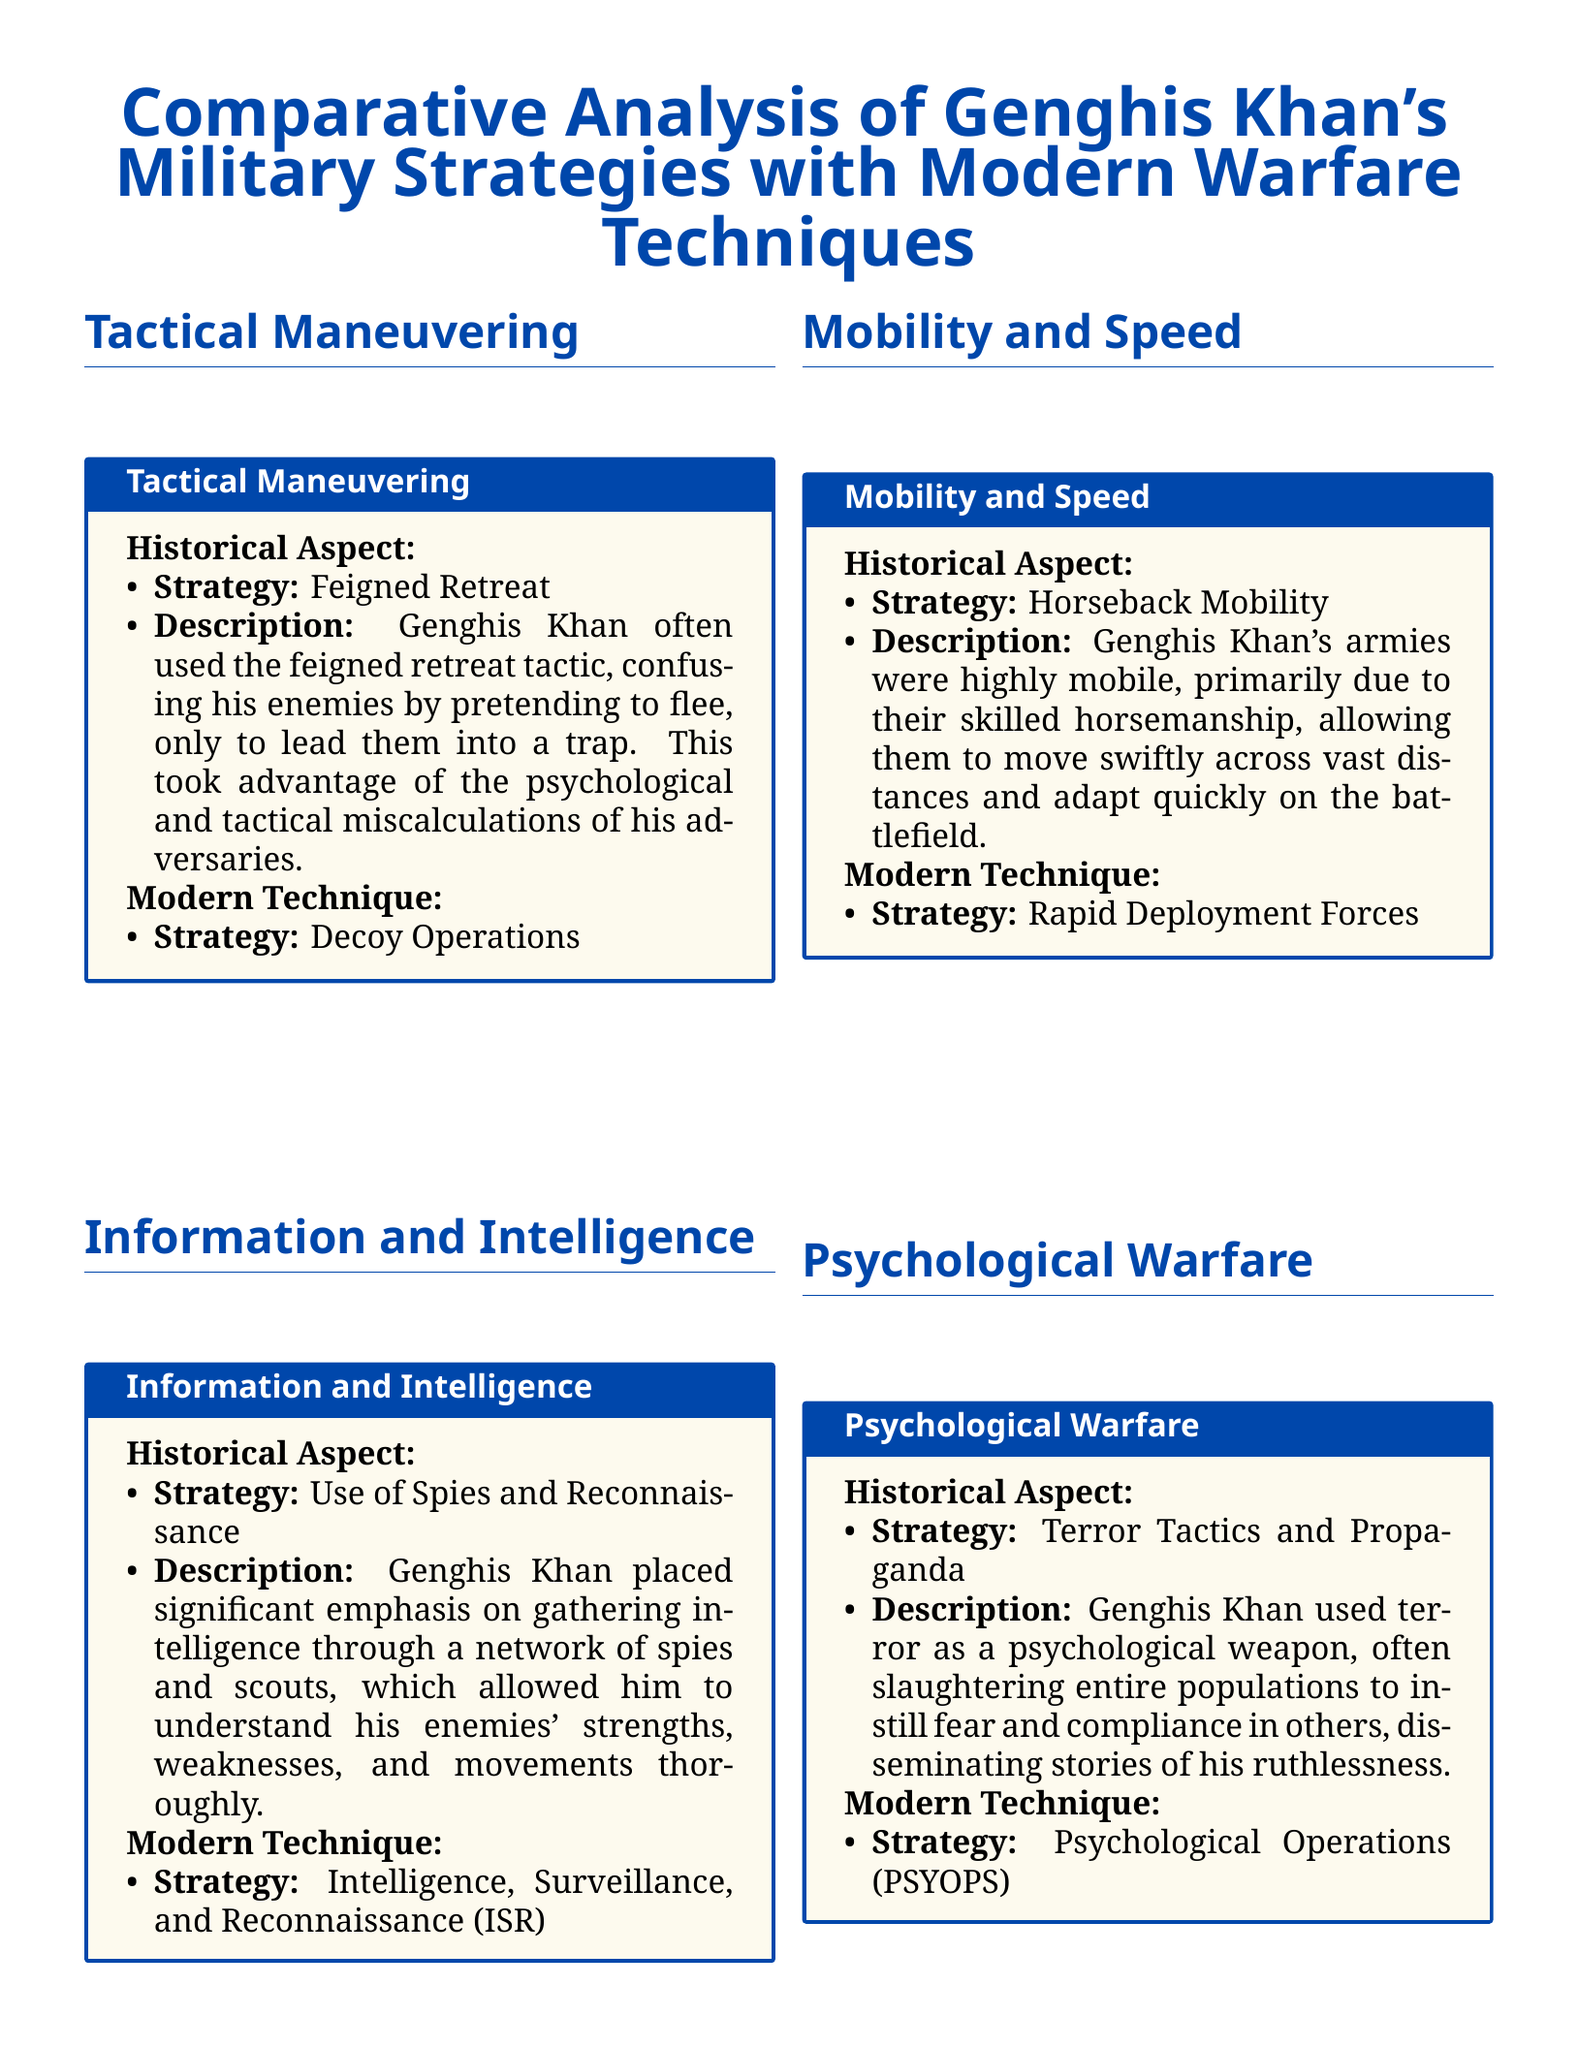What is the first tactic listed for Genghis Khan? The document lists "Feigned Retreat" as the first tactic under Tactical Maneuvering.
Answer: Feigned Retreat What modern technique corresponds with Genghis Khan's use of spies? The corresponding modern technique in the document is "Intelligence, Surveillance, and Reconnaissance (ISR)."
Answer: Intelligence, Surveillance, and Reconnaissance (ISR) How did Genghis Khan ensure mobility in his army? The document states that Genghis Khan's armies were highly mobile primarily due to their skilled horsemanship.
Answer: Horseback Mobility Which psychological tactic did Genghis Khan employ? The document describes "Terror Tactics and Propaganda" as a psychological tactic used by Genghis Khan.
Answer: Terror Tactics and Propaganda What logistics method did Genghis Khan use? The scorecard indicates he utilized a "network of supply points and efficient resource management."
Answer: Supply Points and Resource Management How many military strategies are compared in the document? The document provides a total of five military strategies for comparison.
Answer: Five What color represents the title in the document? The color used for the title in the document is "mongolblue."
Answer: mongolblue What is the main focus of the scorecard? The main focus of the scorecard is the "Comparative Analysis of Genghis Khan's Military Strategies with Modern Warfare Techniques."
Answer: Military Strategies with Modern Warfare Techniques What is the format used to present each strategy? Each strategy is presented in a "tcolorbox" with sections for Historical Aspect and Modern Technique.
Answer: tcolorbox 